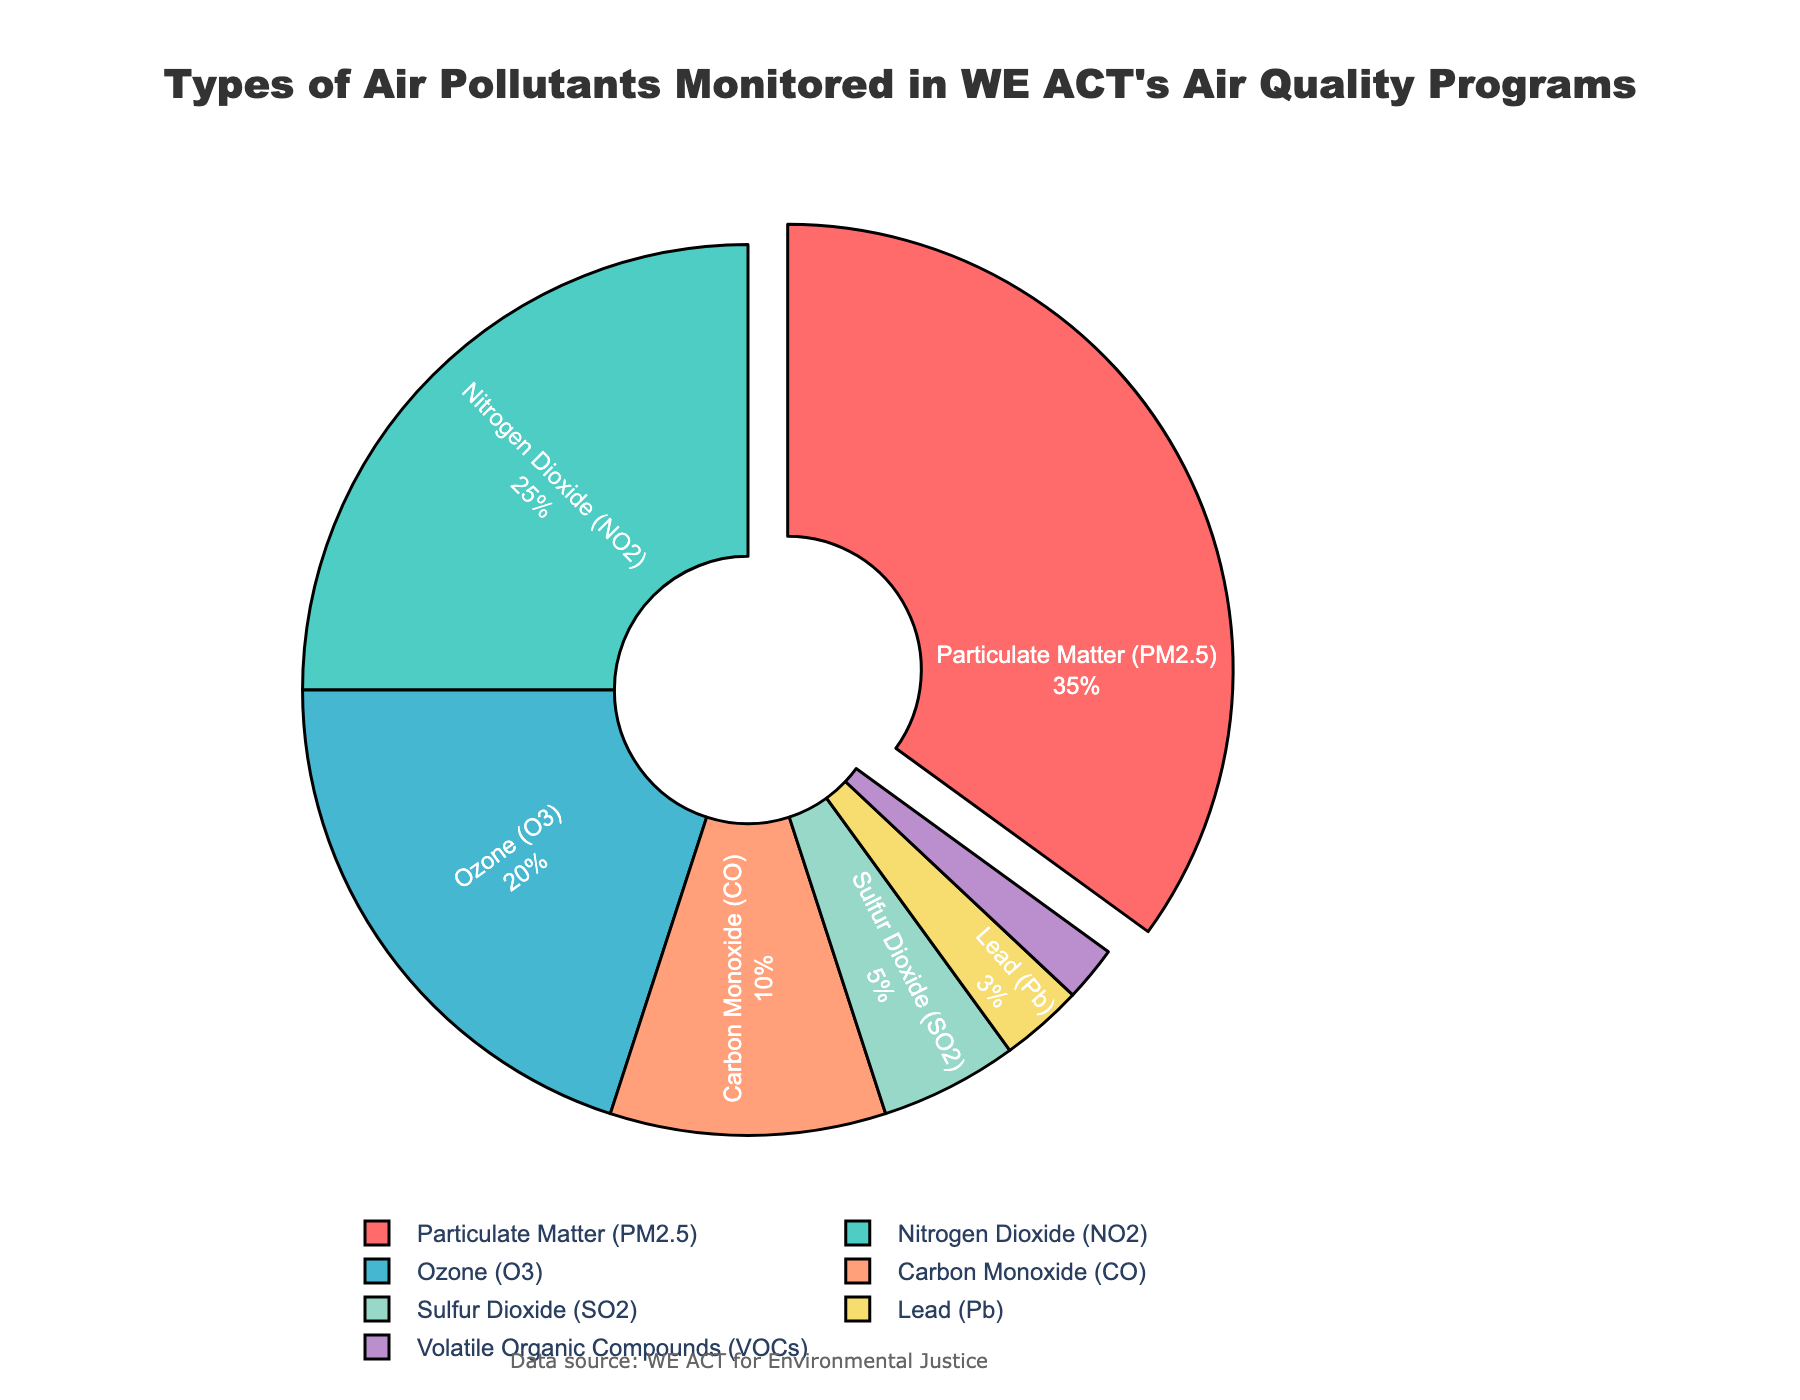What is the most monitored air pollutant in WE ACT's air quality program? Refer to the largest segment of the pie chart. The segment representing Particulate Matter (PM2.5) is the largest, indicating it is the most monitored pollutant.
Answer: Particulate Matter (PM2.5) What percentage of the monitored pollutants does Ozone (O3) represent? Find the segment labeled Ozone (O3) in the pie chart and note its percentage value. It represents 20% of the pollutants monitored.
Answer: 20% What is the combined percentage of Nitrogen Dioxide (NO2) and Ozone (O3)? Sum the percentages of NO2 and O3. NO2 is 25% and O3 is 20%, so 25% + 20% = 45%.
Answer: 45% Which pollutant is monitored the least in WE ACT's air quality program? Identify the smallest segment of the pie chart. The segment for Volatile Organic Compounds (VOCs) is the smallest, indicating it is the least monitored pollutant.
Answer: Volatile Organic Compounds (VOCs) Is the percentage of Nitrogen Dioxide (NO2) monitoring greater than that of Ozone (O3)? Compare the percentage values of NO2 (25%) and O3 (20%). Since 25% is greater than 20%, YES, the monitoring of NO2 is greater.
Answer: Yes What is the total percentage of pollutants monitored that are not Particulate Matter (PM2.5)? Subtract the percentage of PM2.5 from 100%. PM2.5 is 35%, so 100% - 35% = 65%.
Answer: 65% What is the difference in percentage between the monitoring of Carbon Monoxide (CO) and Lead (Pb)? Subtract the percentage of Lead (Pb) from Carbon Monoxide (CO). CO is 10%, and Pb is 3%, so 10% - 3% = 7%.
Answer: 7% Which pollutant segment is represented by a yellow color in the pie chart? Look for the segment with yellow color. The segment for Sulfur Dioxide (SO2) is yellow, as depicted in the pie chart.
Answer: Sulfur Dioxide (SO2) What are the pollutants monitored that collectively make up less than 10% of the total? Identify segments with individual percentages summing to less than 10%. Lead (3%), VOCs (2%), and Sulfur Dioxide (5%) collectively make up 10%.
Answer: Lead (Pb), VOCs Does the combined percentage of Sulfur Dioxide (SO2) and Carbon Monoxide (CO) exceed that of Nitrogen Dioxide (NO2)? Sum the percentages of CO and SO2, and compare with NO2. CO is 10% and SO2 is 5%, so combined, it is 15%. NO2 is 25%. Since 15% is less than 25%, the combined percentage does not exceed NO2.
Answer: No 